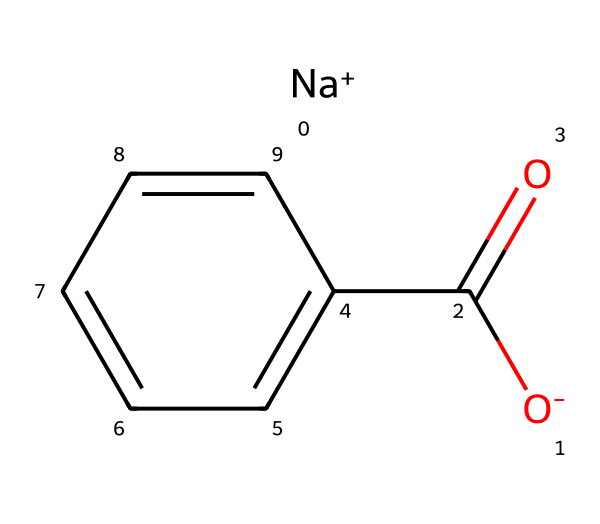What is the name of this chemical? The SMILES representation corresponds to sodium benzoate, which can be identified by the recognizable carboxylate (–COO^-) and the aromatic benzene ring (which has six carbon atoms in a ring). The presence of sodium (Na^+) indicates it is a sodium salt.
Answer: sodium benzoate How many carbon atoms are in the molecule? The visual representation of the chemical shows a benzene ring that consists of six carbon atoms plus one in the carboxyl group; therefore, there are 7 carbon atoms in total.
Answer: seven What is the oxidation state of the sodium in sodium benzoate? Sodium is represented by [Na+], indicating it has lost one electron, which means its oxidation state is +1.
Answer: +1 What type of bond is mainly present between carbon and oxygen in the carboxylate group? In the carboxylate group (–COO^-), the bond between carbon and oxygen is a double bond (as seen in C(=O)), indicating a strong covalent bond that contributes to the reactivity of the molecule.
Answer: double bond What functional groups are present in sodium benzoate? The molecule features a carboxylate group (–COO^-) and a benzene ring, making it aromatic and showing its properties characteristic of preservatives. The carboxylate is specifically essential for its preservative action.
Answer: carboxylate and aromatic Is sodium benzoate soluble in water? Sodium benzoate, being a salt formed with a sodium ion, is generally soluble in water due to its ionic nature, aiding its usage in cleaning products for primate enclosures.
Answer: soluble What is the primary function of sodium benzoate in cleaning products? Sodium benzoate acts primarily as a preservative in cleaning products, preventing the growth of harmful bacteria and fungi that could affect both the cleanliness and the health of primates in enclosures.
Answer: preservative 